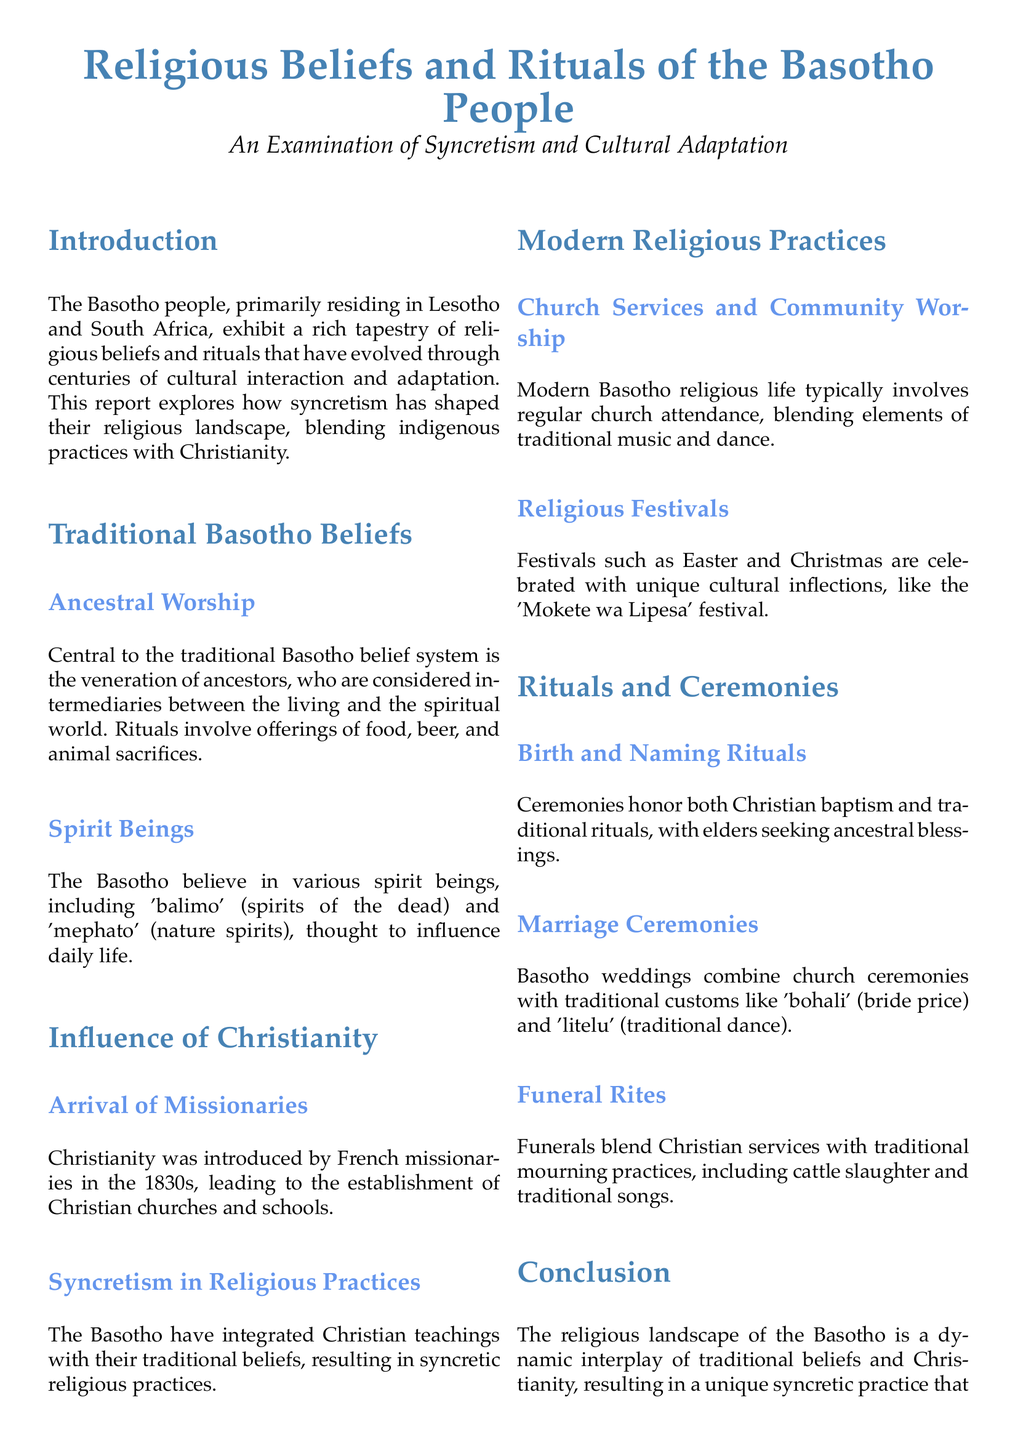What is the main focus of the report? The report examines the syncretism and cultural adaptation of the Basotho people's religious beliefs and rituals.
Answer: Syncretism and cultural adaptation What is central to the traditional Basotho belief system? The document states that ancestor veneration is fundamental to Basotho beliefs.
Answer: Ancestral Worship When were missionaries introduced to the Basotho people? The document mentions that French missionaries arrived in the 1830s.
Answer: 1830s What is the name of the festival celebrated by the Basotho during Christmas? The text refers to a unique festival called 'Mokete wa Lipesa'.
Answer: Mokete wa Lipesa What type of rituals are conducted to honor births among the Basotho? The report highlights ceremonies that combine Christian baptism and traditional rituals.
Answer: Birth and Naming Rituals What traditional practice is included in Basotho wedding ceremonies? The document states that 'bohali' (bride price) is a traditional custom in Basotho weddings.
Answer: Bohali How do funerals among the Basotho reflect their syncretic beliefs? Funerals blend Christian services and traditional mourning practices.
Answer: Blend of Christian and traditional practices What is the document's classification type? The structure and content of the document are based on a lab report format.
Answer: Lab report 